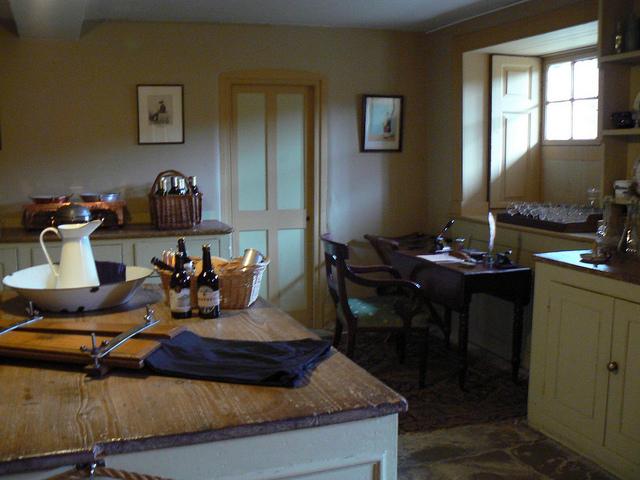What is the blue object on the right?
Answer briefly. Towel. Is there a carpet on the floor?
Be succinct. Yes. What room is this?
Be succinct. Kitchen. Are bottles on the counter?
Be succinct. Yes. What is in the bottle on the table?
Keep it brief. Beer. 